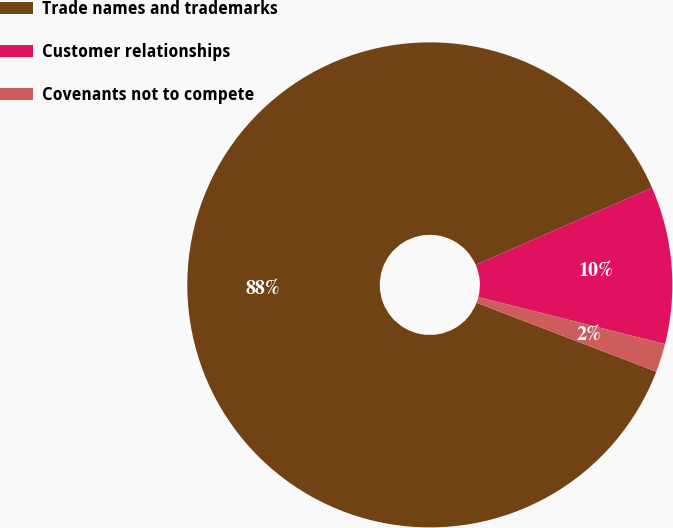Convert chart to OTSL. <chart><loc_0><loc_0><loc_500><loc_500><pie_chart><fcel>Trade names and trademarks<fcel>Customer relationships<fcel>Covenants not to compete<nl><fcel>87.61%<fcel>10.48%<fcel>1.91%<nl></chart> 